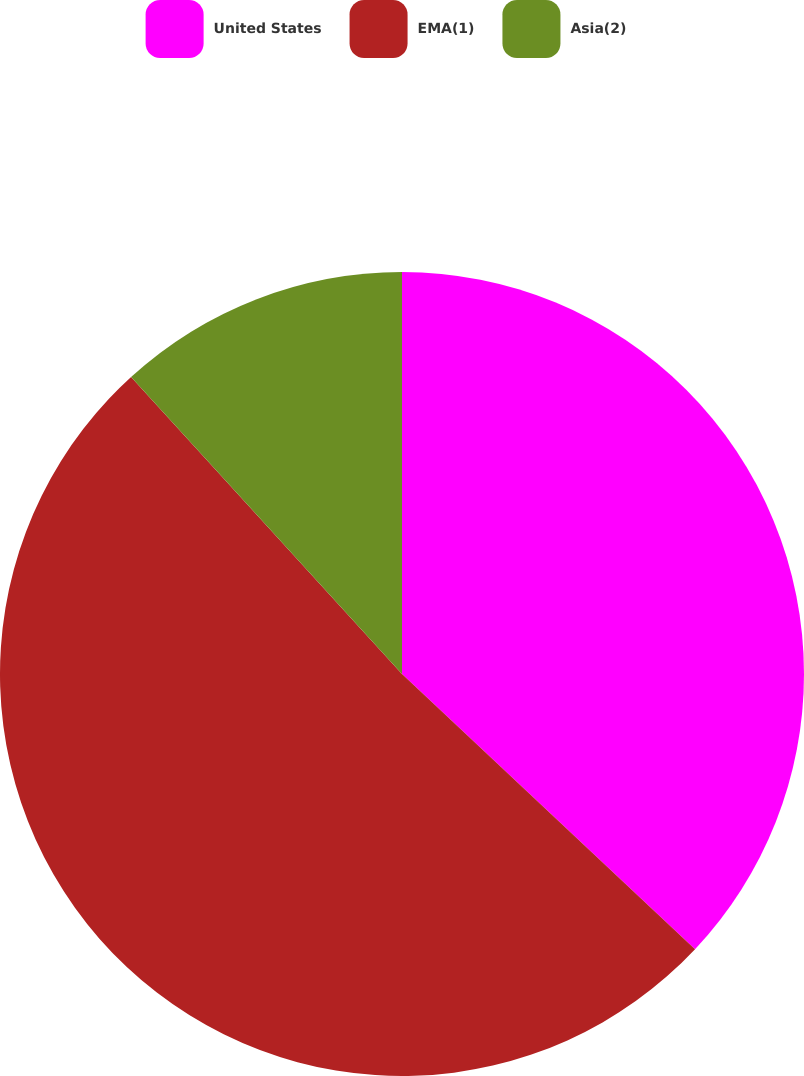<chart> <loc_0><loc_0><loc_500><loc_500><pie_chart><fcel>United States<fcel>EMA(1)<fcel>Asia(2)<nl><fcel>37.0%<fcel>51.23%<fcel>11.77%<nl></chart> 